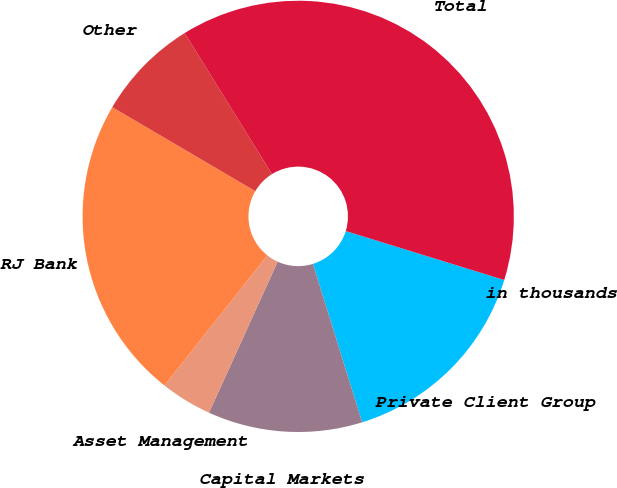Convert chart to OTSL. <chart><loc_0><loc_0><loc_500><loc_500><pie_chart><fcel>in thousands<fcel>Private Client Group<fcel>Capital Markets<fcel>Asset Management<fcel>RJ Bank<fcel>Other<fcel>Total<nl><fcel>0.0%<fcel>15.44%<fcel>11.58%<fcel>3.86%<fcel>22.8%<fcel>7.72%<fcel>38.59%<nl></chart> 